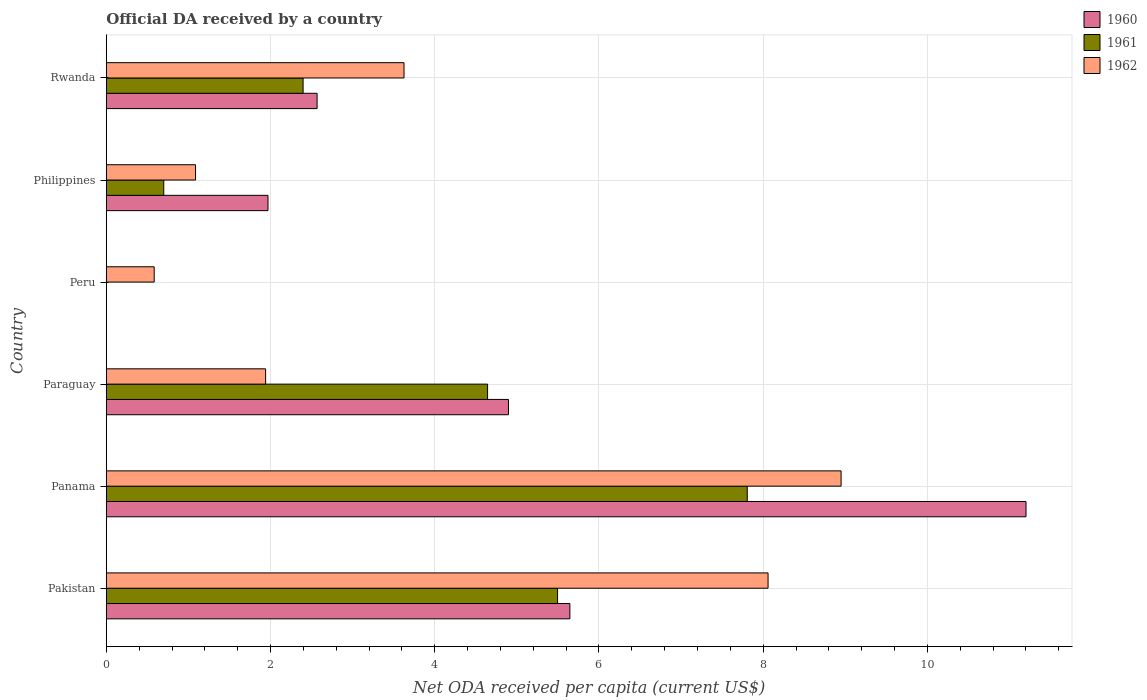How many bars are there on the 1st tick from the bottom?
Give a very brief answer. 3. What is the label of the 4th group of bars from the top?
Your response must be concise. Paraguay. What is the ODA received in in 1960 in Philippines?
Offer a very short reply. 1.97. Across all countries, what is the maximum ODA received in in 1961?
Provide a succinct answer. 7.81. Across all countries, what is the minimum ODA received in in 1962?
Make the answer very short. 0.58. In which country was the ODA received in in 1960 maximum?
Your answer should be very brief. Panama. What is the total ODA received in in 1962 in the graph?
Your response must be concise. 24.24. What is the difference between the ODA received in in 1960 in Pakistan and that in Philippines?
Make the answer very short. 3.68. What is the difference between the ODA received in in 1962 in Rwanda and the ODA received in in 1961 in Panama?
Provide a succinct answer. -4.18. What is the average ODA received in in 1962 per country?
Offer a terse response. 4.04. What is the difference between the ODA received in in 1961 and ODA received in in 1960 in Rwanda?
Ensure brevity in your answer.  -0.17. What is the ratio of the ODA received in in 1962 in Panama to that in Paraguay?
Ensure brevity in your answer.  4.61. What is the difference between the highest and the second highest ODA received in in 1962?
Offer a terse response. 0.89. What is the difference between the highest and the lowest ODA received in in 1962?
Your response must be concise. 8.37. In how many countries, is the ODA received in in 1961 greater than the average ODA received in in 1961 taken over all countries?
Ensure brevity in your answer.  3. How many bars are there?
Your answer should be compact. 16. Are all the bars in the graph horizontal?
Make the answer very short. Yes. How many countries are there in the graph?
Ensure brevity in your answer.  6. Are the values on the major ticks of X-axis written in scientific E-notation?
Keep it short and to the point. No. Does the graph contain grids?
Your answer should be compact. Yes. How many legend labels are there?
Keep it short and to the point. 3. How are the legend labels stacked?
Your response must be concise. Vertical. What is the title of the graph?
Give a very brief answer. Official DA received by a country. Does "1990" appear as one of the legend labels in the graph?
Your answer should be very brief. No. What is the label or title of the X-axis?
Keep it short and to the point. Net ODA received per capita (current US$). What is the Net ODA received per capita (current US$) of 1960 in Pakistan?
Offer a terse response. 5.65. What is the Net ODA received per capita (current US$) of 1961 in Pakistan?
Provide a short and direct response. 5.5. What is the Net ODA received per capita (current US$) of 1962 in Pakistan?
Provide a short and direct response. 8.06. What is the Net ODA received per capita (current US$) in 1960 in Panama?
Your answer should be very brief. 11.2. What is the Net ODA received per capita (current US$) of 1961 in Panama?
Ensure brevity in your answer.  7.81. What is the Net ODA received per capita (current US$) in 1962 in Panama?
Your answer should be very brief. 8.95. What is the Net ODA received per capita (current US$) in 1960 in Paraguay?
Your response must be concise. 4.9. What is the Net ODA received per capita (current US$) of 1961 in Paraguay?
Provide a short and direct response. 4.64. What is the Net ODA received per capita (current US$) of 1962 in Paraguay?
Provide a succinct answer. 1.94. What is the Net ODA received per capita (current US$) in 1960 in Peru?
Your response must be concise. 0. What is the Net ODA received per capita (current US$) in 1961 in Peru?
Keep it short and to the point. 0. What is the Net ODA received per capita (current US$) of 1962 in Peru?
Give a very brief answer. 0.58. What is the Net ODA received per capita (current US$) in 1960 in Philippines?
Your answer should be compact. 1.97. What is the Net ODA received per capita (current US$) in 1961 in Philippines?
Your answer should be compact. 0.7. What is the Net ODA received per capita (current US$) of 1962 in Philippines?
Provide a short and direct response. 1.09. What is the Net ODA received per capita (current US$) of 1960 in Rwanda?
Make the answer very short. 2.57. What is the Net ODA received per capita (current US$) in 1961 in Rwanda?
Provide a short and direct response. 2.4. What is the Net ODA received per capita (current US$) of 1962 in Rwanda?
Keep it short and to the point. 3.63. Across all countries, what is the maximum Net ODA received per capita (current US$) in 1960?
Your answer should be compact. 11.2. Across all countries, what is the maximum Net ODA received per capita (current US$) in 1961?
Offer a terse response. 7.81. Across all countries, what is the maximum Net ODA received per capita (current US$) in 1962?
Provide a short and direct response. 8.95. Across all countries, what is the minimum Net ODA received per capita (current US$) of 1960?
Offer a very short reply. 0. Across all countries, what is the minimum Net ODA received per capita (current US$) in 1961?
Provide a short and direct response. 0. Across all countries, what is the minimum Net ODA received per capita (current US$) of 1962?
Your answer should be compact. 0.58. What is the total Net ODA received per capita (current US$) in 1960 in the graph?
Your response must be concise. 26.28. What is the total Net ODA received per capita (current US$) in 1961 in the graph?
Give a very brief answer. 21.04. What is the total Net ODA received per capita (current US$) of 1962 in the graph?
Give a very brief answer. 24.24. What is the difference between the Net ODA received per capita (current US$) in 1960 in Pakistan and that in Panama?
Your answer should be very brief. -5.56. What is the difference between the Net ODA received per capita (current US$) in 1961 in Pakistan and that in Panama?
Your response must be concise. -2.31. What is the difference between the Net ODA received per capita (current US$) of 1962 in Pakistan and that in Panama?
Provide a succinct answer. -0.89. What is the difference between the Net ODA received per capita (current US$) of 1960 in Pakistan and that in Paraguay?
Offer a terse response. 0.75. What is the difference between the Net ODA received per capita (current US$) of 1961 in Pakistan and that in Paraguay?
Your response must be concise. 0.85. What is the difference between the Net ODA received per capita (current US$) of 1962 in Pakistan and that in Paraguay?
Give a very brief answer. 6.12. What is the difference between the Net ODA received per capita (current US$) in 1962 in Pakistan and that in Peru?
Your answer should be compact. 7.48. What is the difference between the Net ODA received per capita (current US$) of 1960 in Pakistan and that in Philippines?
Your answer should be compact. 3.68. What is the difference between the Net ODA received per capita (current US$) in 1961 in Pakistan and that in Philippines?
Provide a succinct answer. 4.8. What is the difference between the Net ODA received per capita (current US$) of 1962 in Pakistan and that in Philippines?
Give a very brief answer. 6.97. What is the difference between the Net ODA received per capita (current US$) in 1960 in Pakistan and that in Rwanda?
Your answer should be compact. 3.08. What is the difference between the Net ODA received per capita (current US$) of 1961 in Pakistan and that in Rwanda?
Offer a very short reply. 3.1. What is the difference between the Net ODA received per capita (current US$) of 1962 in Pakistan and that in Rwanda?
Provide a succinct answer. 4.43. What is the difference between the Net ODA received per capita (current US$) in 1960 in Panama and that in Paraguay?
Give a very brief answer. 6.3. What is the difference between the Net ODA received per capita (current US$) of 1961 in Panama and that in Paraguay?
Keep it short and to the point. 3.16. What is the difference between the Net ODA received per capita (current US$) in 1962 in Panama and that in Paraguay?
Keep it short and to the point. 7.01. What is the difference between the Net ODA received per capita (current US$) in 1962 in Panama and that in Peru?
Give a very brief answer. 8.37. What is the difference between the Net ODA received per capita (current US$) of 1960 in Panama and that in Philippines?
Your answer should be compact. 9.23. What is the difference between the Net ODA received per capita (current US$) in 1961 in Panama and that in Philippines?
Your answer should be very brief. 7.11. What is the difference between the Net ODA received per capita (current US$) in 1962 in Panama and that in Philippines?
Your response must be concise. 7.86. What is the difference between the Net ODA received per capita (current US$) of 1960 in Panama and that in Rwanda?
Your answer should be compact. 8.63. What is the difference between the Net ODA received per capita (current US$) of 1961 in Panama and that in Rwanda?
Offer a very short reply. 5.41. What is the difference between the Net ODA received per capita (current US$) of 1962 in Panama and that in Rwanda?
Provide a succinct answer. 5.32. What is the difference between the Net ODA received per capita (current US$) in 1962 in Paraguay and that in Peru?
Provide a succinct answer. 1.36. What is the difference between the Net ODA received per capita (current US$) in 1960 in Paraguay and that in Philippines?
Make the answer very short. 2.93. What is the difference between the Net ODA received per capita (current US$) of 1961 in Paraguay and that in Philippines?
Ensure brevity in your answer.  3.94. What is the difference between the Net ODA received per capita (current US$) in 1962 in Paraguay and that in Philippines?
Offer a terse response. 0.85. What is the difference between the Net ODA received per capita (current US$) of 1960 in Paraguay and that in Rwanda?
Keep it short and to the point. 2.33. What is the difference between the Net ODA received per capita (current US$) of 1961 in Paraguay and that in Rwanda?
Provide a succinct answer. 2.25. What is the difference between the Net ODA received per capita (current US$) of 1962 in Paraguay and that in Rwanda?
Your response must be concise. -1.69. What is the difference between the Net ODA received per capita (current US$) in 1962 in Peru and that in Philippines?
Make the answer very short. -0.5. What is the difference between the Net ODA received per capita (current US$) of 1962 in Peru and that in Rwanda?
Provide a short and direct response. -3.04. What is the difference between the Net ODA received per capita (current US$) of 1960 in Philippines and that in Rwanda?
Offer a very short reply. -0.6. What is the difference between the Net ODA received per capita (current US$) in 1961 in Philippines and that in Rwanda?
Offer a very short reply. -1.7. What is the difference between the Net ODA received per capita (current US$) in 1962 in Philippines and that in Rwanda?
Offer a very short reply. -2.54. What is the difference between the Net ODA received per capita (current US$) in 1960 in Pakistan and the Net ODA received per capita (current US$) in 1961 in Panama?
Keep it short and to the point. -2.16. What is the difference between the Net ODA received per capita (current US$) in 1960 in Pakistan and the Net ODA received per capita (current US$) in 1962 in Panama?
Provide a short and direct response. -3.3. What is the difference between the Net ODA received per capita (current US$) of 1961 in Pakistan and the Net ODA received per capita (current US$) of 1962 in Panama?
Your response must be concise. -3.45. What is the difference between the Net ODA received per capita (current US$) of 1960 in Pakistan and the Net ODA received per capita (current US$) of 1961 in Paraguay?
Make the answer very short. 1. What is the difference between the Net ODA received per capita (current US$) in 1960 in Pakistan and the Net ODA received per capita (current US$) in 1962 in Paraguay?
Your response must be concise. 3.71. What is the difference between the Net ODA received per capita (current US$) in 1961 in Pakistan and the Net ODA received per capita (current US$) in 1962 in Paraguay?
Your answer should be compact. 3.56. What is the difference between the Net ODA received per capita (current US$) of 1960 in Pakistan and the Net ODA received per capita (current US$) of 1962 in Peru?
Your answer should be compact. 5.06. What is the difference between the Net ODA received per capita (current US$) in 1961 in Pakistan and the Net ODA received per capita (current US$) in 1962 in Peru?
Your answer should be compact. 4.91. What is the difference between the Net ODA received per capita (current US$) of 1960 in Pakistan and the Net ODA received per capita (current US$) of 1961 in Philippines?
Your response must be concise. 4.95. What is the difference between the Net ODA received per capita (current US$) in 1960 in Pakistan and the Net ODA received per capita (current US$) in 1962 in Philippines?
Offer a terse response. 4.56. What is the difference between the Net ODA received per capita (current US$) of 1961 in Pakistan and the Net ODA received per capita (current US$) of 1962 in Philippines?
Your response must be concise. 4.41. What is the difference between the Net ODA received per capita (current US$) of 1960 in Pakistan and the Net ODA received per capita (current US$) of 1961 in Rwanda?
Your answer should be very brief. 3.25. What is the difference between the Net ODA received per capita (current US$) of 1960 in Pakistan and the Net ODA received per capita (current US$) of 1962 in Rwanda?
Provide a succinct answer. 2.02. What is the difference between the Net ODA received per capita (current US$) of 1961 in Pakistan and the Net ODA received per capita (current US$) of 1962 in Rwanda?
Offer a terse response. 1.87. What is the difference between the Net ODA received per capita (current US$) of 1960 in Panama and the Net ODA received per capita (current US$) of 1961 in Paraguay?
Your response must be concise. 6.56. What is the difference between the Net ODA received per capita (current US$) of 1960 in Panama and the Net ODA received per capita (current US$) of 1962 in Paraguay?
Provide a short and direct response. 9.26. What is the difference between the Net ODA received per capita (current US$) in 1961 in Panama and the Net ODA received per capita (current US$) in 1962 in Paraguay?
Provide a succinct answer. 5.87. What is the difference between the Net ODA received per capita (current US$) of 1960 in Panama and the Net ODA received per capita (current US$) of 1962 in Peru?
Provide a short and direct response. 10.62. What is the difference between the Net ODA received per capita (current US$) of 1961 in Panama and the Net ODA received per capita (current US$) of 1962 in Peru?
Give a very brief answer. 7.22. What is the difference between the Net ODA received per capita (current US$) in 1960 in Panama and the Net ODA received per capita (current US$) in 1961 in Philippines?
Offer a terse response. 10.5. What is the difference between the Net ODA received per capita (current US$) of 1960 in Panama and the Net ODA received per capita (current US$) of 1962 in Philippines?
Offer a very short reply. 10.11. What is the difference between the Net ODA received per capita (current US$) of 1961 in Panama and the Net ODA received per capita (current US$) of 1962 in Philippines?
Offer a terse response. 6.72. What is the difference between the Net ODA received per capita (current US$) of 1960 in Panama and the Net ODA received per capita (current US$) of 1961 in Rwanda?
Ensure brevity in your answer.  8.8. What is the difference between the Net ODA received per capita (current US$) in 1960 in Panama and the Net ODA received per capita (current US$) in 1962 in Rwanda?
Make the answer very short. 7.58. What is the difference between the Net ODA received per capita (current US$) of 1961 in Panama and the Net ODA received per capita (current US$) of 1962 in Rwanda?
Ensure brevity in your answer.  4.18. What is the difference between the Net ODA received per capita (current US$) of 1960 in Paraguay and the Net ODA received per capita (current US$) of 1962 in Peru?
Your answer should be very brief. 4.31. What is the difference between the Net ODA received per capita (current US$) in 1961 in Paraguay and the Net ODA received per capita (current US$) in 1962 in Peru?
Make the answer very short. 4.06. What is the difference between the Net ODA received per capita (current US$) in 1960 in Paraguay and the Net ODA received per capita (current US$) in 1961 in Philippines?
Make the answer very short. 4.2. What is the difference between the Net ODA received per capita (current US$) in 1960 in Paraguay and the Net ODA received per capita (current US$) in 1962 in Philippines?
Provide a succinct answer. 3.81. What is the difference between the Net ODA received per capita (current US$) in 1961 in Paraguay and the Net ODA received per capita (current US$) in 1962 in Philippines?
Offer a very short reply. 3.56. What is the difference between the Net ODA received per capita (current US$) of 1960 in Paraguay and the Net ODA received per capita (current US$) of 1961 in Rwanda?
Offer a terse response. 2.5. What is the difference between the Net ODA received per capita (current US$) in 1960 in Paraguay and the Net ODA received per capita (current US$) in 1962 in Rwanda?
Your answer should be compact. 1.27. What is the difference between the Net ODA received per capita (current US$) in 1961 in Paraguay and the Net ODA received per capita (current US$) in 1962 in Rwanda?
Ensure brevity in your answer.  1.02. What is the difference between the Net ODA received per capita (current US$) in 1960 in Philippines and the Net ODA received per capita (current US$) in 1961 in Rwanda?
Your answer should be very brief. -0.43. What is the difference between the Net ODA received per capita (current US$) of 1960 in Philippines and the Net ODA received per capita (current US$) of 1962 in Rwanda?
Ensure brevity in your answer.  -1.66. What is the difference between the Net ODA received per capita (current US$) in 1961 in Philippines and the Net ODA received per capita (current US$) in 1962 in Rwanda?
Give a very brief answer. -2.93. What is the average Net ODA received per capita (current US$) of 1960 per country?
Ensure brevity in your answer.  4.38. What is the average Net ODA received per capita (current US$) in 1961 per country?
Provide a succinct answer. 3.51. What is the average Net ODA received per capita (current US$) in 1962 per country?
Make the answer very short. 4.04. What is the difference between the Net ODA received per capita (current US$) of 1960 and Net ODA received per capita (current US$) of 1962 in Pakistan?
Make the answer very short. -2.41. What is the difference between the Net ODA received per capita (current US$) in 1961 and Net ODA received per capita (current US$) in 1962 in Pakistan?
Offer a terse response. -2.56. What is the difference between the Net ODA received per capita (current US$) in 1960 and Net ODA received per capita (current US$) in 1961 in Panama?
Offer a terse response. 3.4. What is the difference between the Net ODA received per capita (current US$) in 1960 and Net ODA received per capita (current US$) in 1962 in Panama?
Your answer should be compact. 2.25. What is the difference between the Net ODA received per capita (current US$) of 1961 and Net ODA received per capita (current US$) of 1962 in Panama?
Your answer should be very brief. -1.14. What is the difference between the Net ODA received per capita (current US$) in 1960 and Net ODA received per capita (current US$) in 1961 in Paraguay?
Ensure brevity in your answer.  0.25. What is the difference between the Net ODA received per capita (current US$) in 1960 and Net ODA received per capita (current US$) in 1962 in Paraguay?
Your answer should be compact. 2.96. What is the difference between the Net ODA received per capita (current US$) of 1961 and Net ODA received per capita (current US$) of 1962 in Paraguay?
Your answer should be very brief. 2.7. What is the difference between the Net ODA received per capita (current US$) of 1960 and Net ODA received per capita (current US$) of 1961 in Philippines?
Provide a succinct answer. 1.27. What is the difference between the Net ODA received per capita (current US$) in 1960 and Net ODA received per capita (current US$) in 1962 in Philippines?
Your answer should be compact. 0.88. What is the difference between the Net ODA received per capita (current US$) in 1961 and Net ODA received per capita (current US$) in 1962 in Philippines?
Offer a terse response. -0.39. What is the difference between the Net ODA received per capita (current US$) of 1960 and Net ODA received per capita (current US$) of 1961 in Rwanda?
Make the answer very short. 0.17. What is the difference between the Net ODA received per capita (current US$) in 1960 and Net ODA received per capita (current US$) in 1962 in Rwanda?
Make the answer very short. -1.06. What is the difference between the Net ODA received per capita (current US$) of 1961 and Net ODA received per capita (current US$) of 1962 in Rwanda?
Provide a short and direct response. -1.23. What is the ratio of the Net ODA received per capita (current US$) in 1960 in Pakistan to that in Panama?
Your answer should be very brief. 0.5. What is the ratio of the Net ODA received per capita (current US$) of 1961 in Pakistan to that in Panama?
Your answer should be very brief. 0.7. What is the ratio of the Net ODA received per capita (current US$) in 1962 in Pakistan to that in Panama?
Make the answer very short. 0.9. What is the ratio of the Net ODA received per capita (current US$) of 1960 in Pakistan to that in Paraguay?
Offer a very short reply. 1.15. What is the ratio of the Net ODA received per capita (current US$) in 1961 in Pakistan to that in Paraguay?
Provide a succinct answer. 1.18. What is the ratio of the Net ODA received per capita (current US$) of 1962 in Pakistan to that in Paraguay?
Give a very brief answer. 4.15. What is the ratio of the Net ODA received per capita (current US$) of 1962 in Pakistan to that in Peru?
Provide a succinct answer. 13.82. What is the ratio of the Net ODA received per capita (current US$) of 1960 in Pakistan to that in Philippines?
Your answer should be compact. 2.87. What is the ratio of the Net ODA received per capita (current US$) of 1961 in Pakistan to that in Philippines?
Offer a very short reply. 7.86. What is the ratio of the Net ODA received per capita (current US$) in 1962 in Pakistan to that in Philippines?
Your answer should be very brief. 7.42. What is the ratio of the Net ODA received per capita (current US$) in 1960 in Pakistan to that in Rwanda?
Keep it short and to the point. 2.2. What is the ratio of the Net ODA received per capita (current US$) in 1961 in Pakistan to that in Rwanda?
Give a very brief answer. 2.29. What is the ratio of the Net ODA received per capita (current US$) in 1962 in Pakistan to that in Rwanda?
Give a very brief answer. 2.22. What is the ratio of the Net ODA received per capita (current US$) of 1960 in Panama to that in Paraguay?
Provide a short and direct response. 2.29. What is the ratio of the Net ODA received per capita (current US$) in 1961 in Panama to that in Paraguay?
Your response must be concise. 1.68. What is the ratio of the Net ODA received per capita (current US$) in 1962 in Panama to that in Paraguay?
Your answer should be very brief. 4.61. What is the ratio of the Net ODA received per capita (current US$) in 1962 in Panama to that in Peru?
Offer a very short reply. 15.35. What is the ratio of the Net ODA received per capita (current US$) of 1960 in Panama to that in Philippines?
Keep it short and to the point. 5.69. What is the ratio of the Net ODA received per capita (current US$) of 1961 in Panama to that in Philippines?
Provide a short and direct response. 11.16. What is the ratio of the Net ODA received per capita (current US$) of 1962 in Panama to that in Philippines?
Ensure brevity in your answer.  8.24. What is the ratio of the Net ODA received per capita (current US$) in 1960 in Panama to that in Rwanda?
Make the answer very short. 4.36. What is the ratio of the Net ODA received per capita (current US$) of 1961 in Panama to that in Rwanda?
Offer a terse response. 3.26. What is the ratio of the Net ODA received per capita (current US$) of 1962 in Panama to that in Rwanda?
Your answer should be compact. 2.47. What is the ratio of the Net ODA received per capita (current US$) of 1962 in Paraguay to that in Peru?
Your answer should be very brief. 3.33. What is the ratio of the Net ODA received per capita (current US$) of 1960 in Paraguay to that in Philippines?
Offer a terse response. 2.49. What is the ratio of the Net ODA received per capita (current US$) in 1961 in Paraguay to that in Philippines?
Your answer should be very brief. 6.64. What is the ratio of the Net ODA received per capita (current US$) of 1962 in Paraguay to that in Philippines?
Offer a very short reply. 1.79. What is the ratio of the Net ODA received per capita (current US$) of 1960 in Paraguay to that in Rwanda?
Ensure brevity in your answer.  1.91. What is the ratio of the Net ODA received per capita (current US$) of 1961 in Paraguay to that in Rwanda?
Your answer should be very brief. 1.94. What is the ratio of the Net ODA received per capita (current US$) in 1962 in Paraguay to that in Rwanda?
Provide a short and direct response. 0.54. What is the ratio of the Net ODA received per capita (current US$) in 1962 in Peru to that in Philippines?
Offer a very short reply. 0.54. What is the ratio of the Net ODA received per capita (current US$) in 1962 in Peru to that in Rwanda?
Give a very brief answer. 0.16. What is the ratio of the Net ODA received per capita (current US$) of 1960 in Philippines to that in Rwanda?
Your response must be concise. 0.77. What is the ratio of the Net ODA received per capita (current US$) of 1961 in Philippines to that in Rwanda?
Offer a terse response. 0.29. What is the ratio of the Net ODA received per capita (current US$) of 1962 in Philippines to that in Rwanda?
Keep it short and to the point. 0.3. What is the difference between the highest and the second highest Net ODA received per capita (current US$) in 1960?
Ensure brevity in your answer.  5.56. What is the difference between the highest and the second highest Net ODA received per capita (current US$) of 1961?
Ensure brevity in your answer.  2.31. What is the difference between the highest and the second highest Net ODA received per capita (current US$) of 1962?
Your answer should be compact. 0.89. What is the difference between the highest and the lowest Net ODA received per capita (current US$) of 1960?
Your response must be concise. 11.2. What is the difference between the highest and the lowest Net ODA received per capita (current US$) of 1961?
Make the answer very short. 7.81. What is the difference between the highest and the lowest Net ODA received per capita (current US$) in 1962?
Provide a succinct answer. 8.37. 